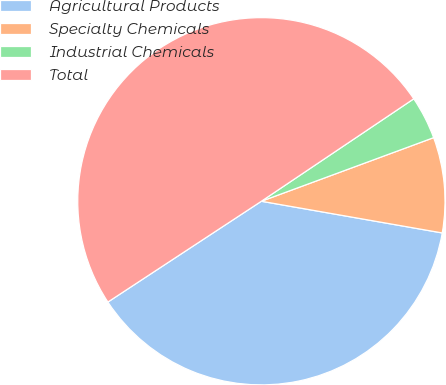Convert chart to OTSL. <chart><loc_0><loc_0><loc_500><loc_500><pie_chart><fcel>Agricultural Products<fcel>Specialty Chemicals<fcel>Industrial Chemicals<fcel>Total<nl><fcel>37.99%<fcel>8.39%<fcel>3.79%<fcel>49.83%<nl></chart> 